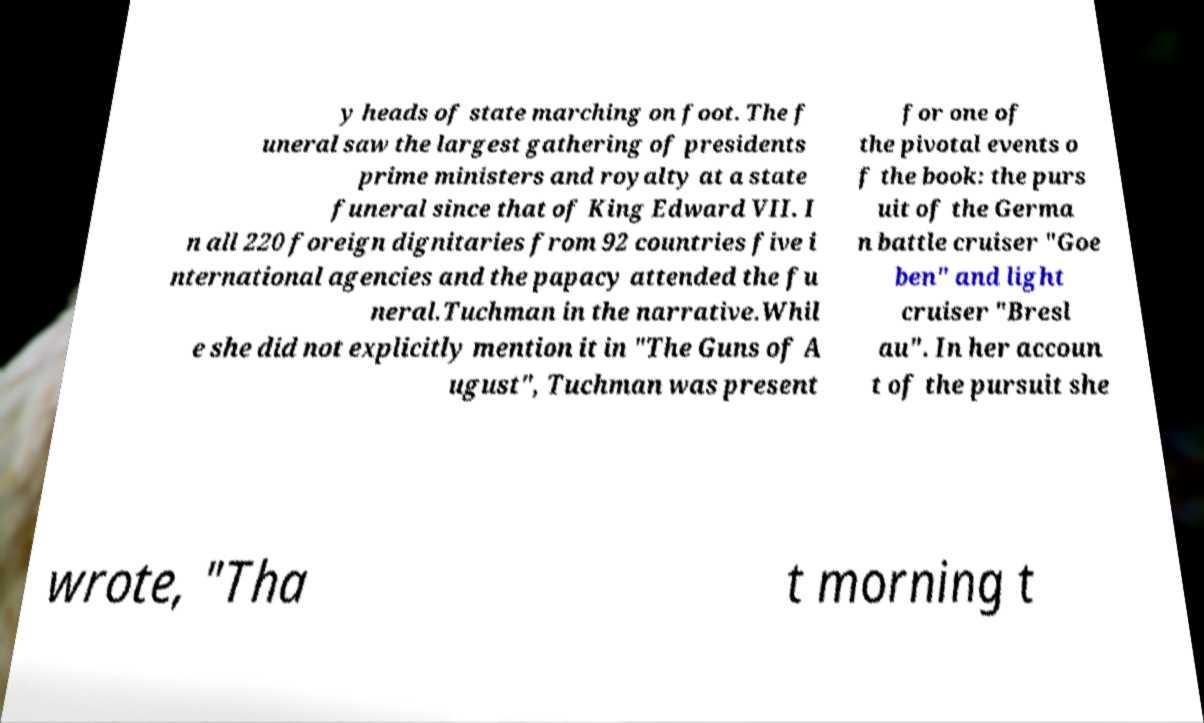There's text embedded in this image that I need extracted. Can you transcribe it verbatim? y heads of state marching on foot. The f uneral saw the largest gathering of presidents prime ministers and royalty at a state funeral since that of King Edward VII. I n all 220 foreign dignitaries from 92 countries five i nternational agencies and the papacy attended the fu neral.Tuchman in the narrative.Whil e she did not explicitly mention it in "The Guns of A ugust", Tuchman was present for one of the pivotal events o f the book: the purs uit of the Germa n battle cruiser "Goe ben" and light cruiser "Bresl au". In her accoun t of the pursuit she wrote, "Tha t morning t 